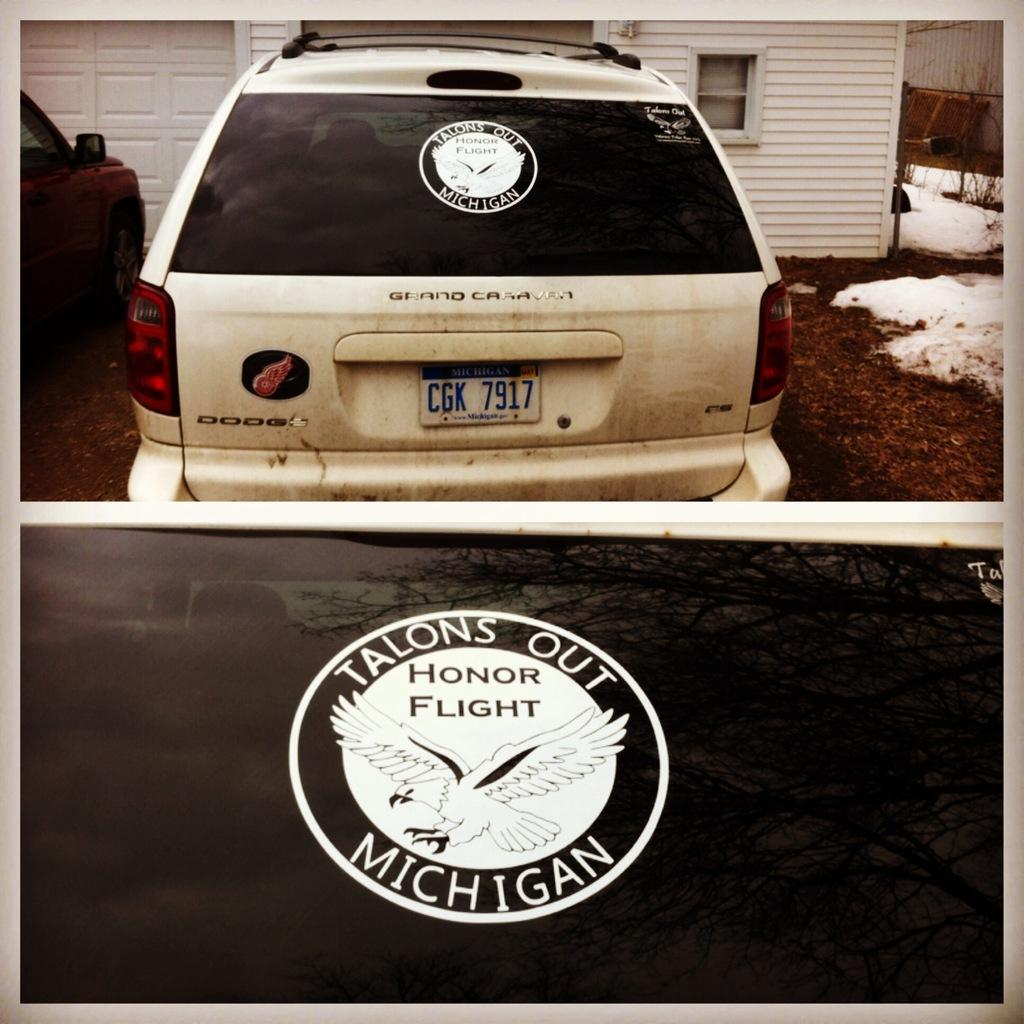What is written or displayed at the bottom of the image? There is some text at the bottom of the image. What vehicles can be seen in the image? There are two cars in the front of the image. What type of structure is visible in the background? There is a house in the background of the image. What is the condition of the ground on the right side of the image? Snow and grass are visible on the right side of the image. What type of creature can be seen playing with a pencil in the image? There is no creature or pencil present in the image. What direction is the sun shining from in the image? The image does not show the sun, so it is not possible to determine the direction of sunlight. 